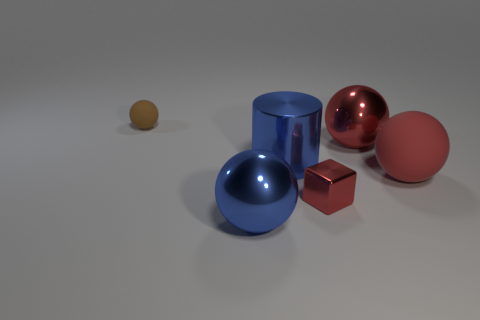Subtract all balls. How many objects are left? 2 Subtract 1 cylinders. How many cylinders are left? 0 Subtract all gray blocks. Subtract all green cylinders. How many blocks are left? 1 Subtract all gray blocks. How many blue balls are left? 1 Subtract all big blue metallic spheres. Subtract all large red matte things. How many objects are left? 4 Add 2 brown matte spheres. How many brown matte spheres are left? 3 Add 3 large spheres. How many large spheres exist? 6 Add 1 large yellow matte blocks. How many objects exist? 7 Subtract all blue spheres. How many spheres are left? 3 Subtract all large blue metal balls. How many balls are left? 3 